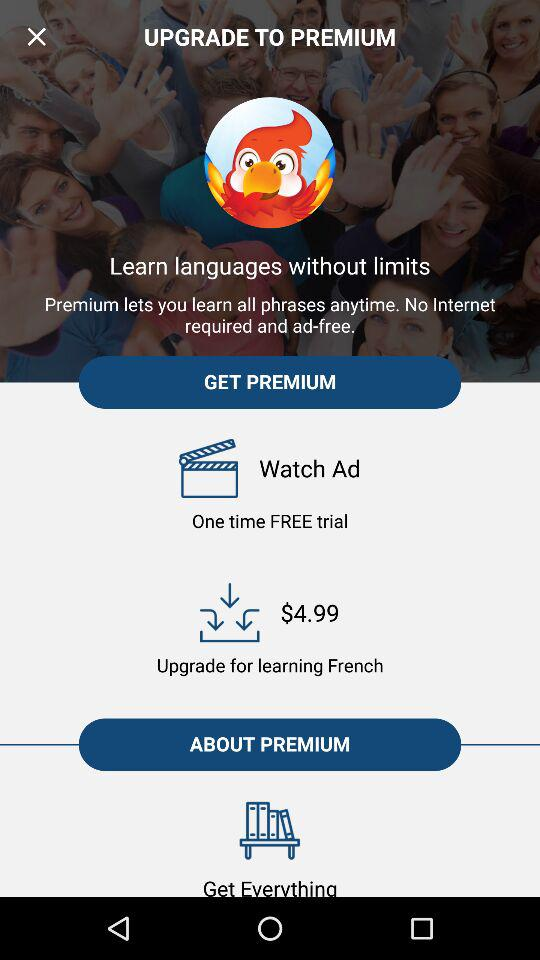How much is it to upgrade to premium to learn French?
Answer the question using a single word or phrase. $4.99 